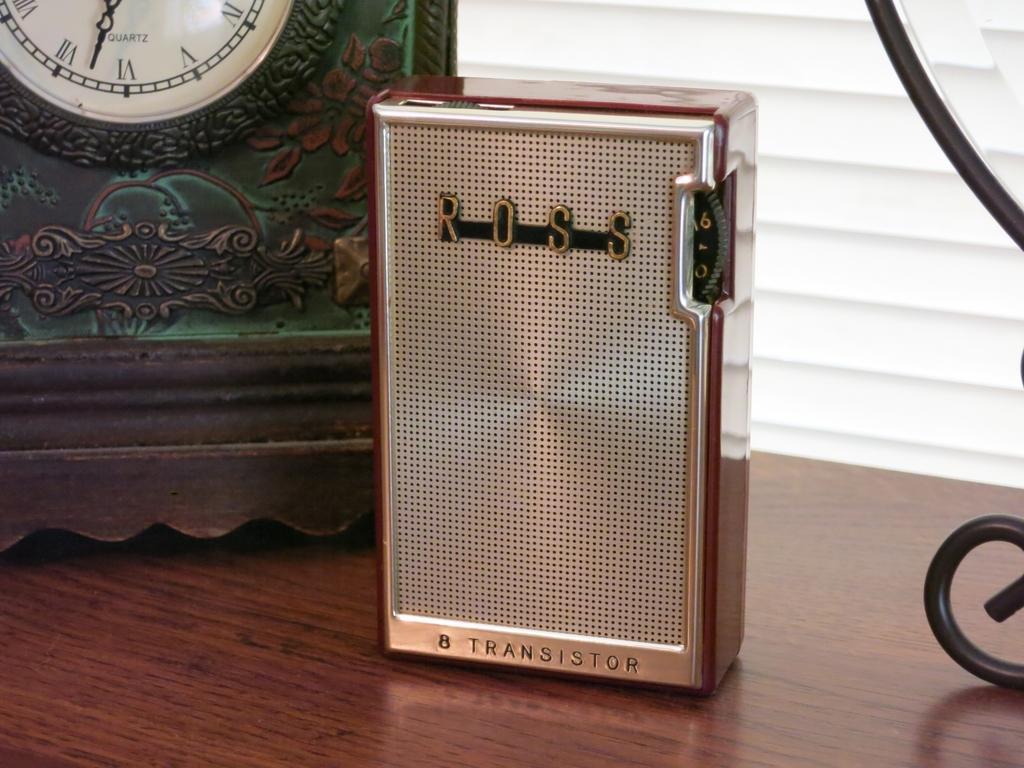Please provide a concise description of this image. At the bottom of the image there is a table and we can see a transistor, a clock and a stand placed on the table. 